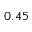Convert formula to latex. <formula><loc_0><loc_0><loc_500><loc_500>0 . 4 5</formula> 